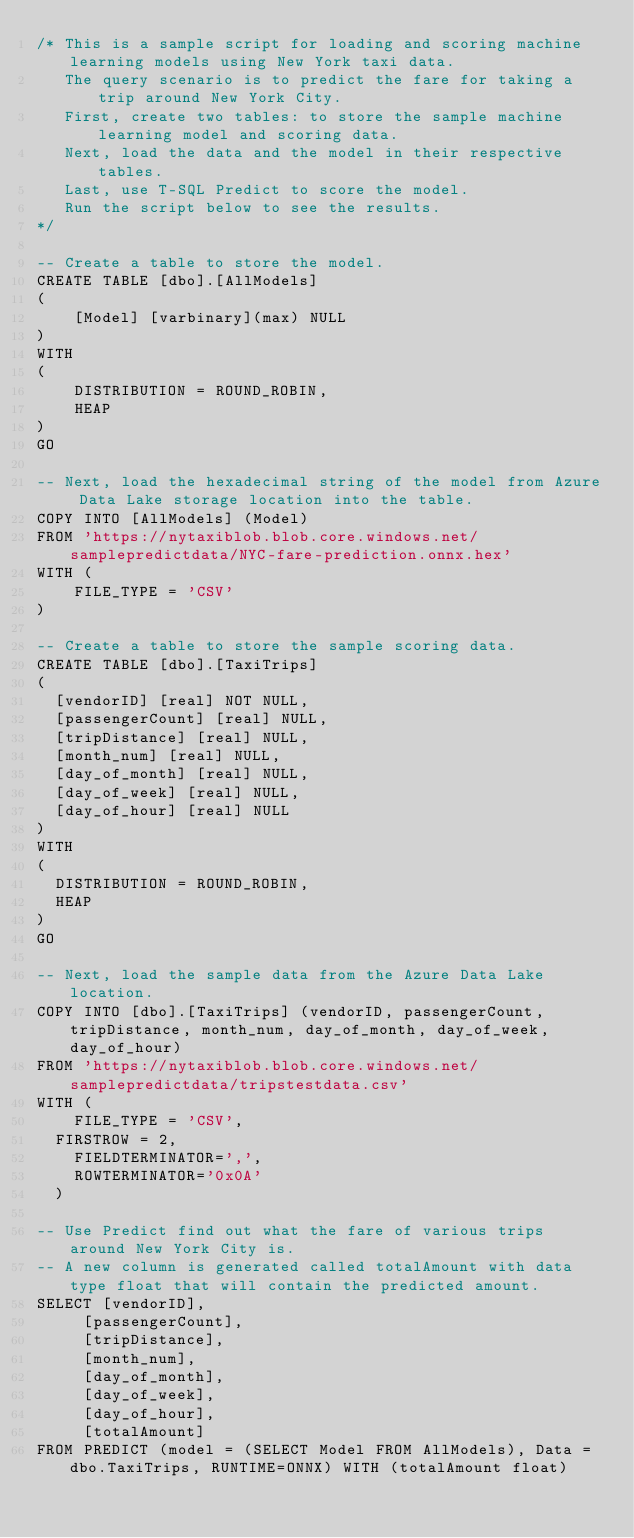<code> <loc_0><loc_0><loc_500><loc_500><_SQL_>/* This is a sample script for loading and scoring machine learning models using New York taxi data.
   The query scenario is to predict the fare for taking a trip around New York City.
   First, create two tables: to store the sample machine learning model and scoring data.
   Next, load the data and the model in their respective tables.
   Last, use T-SQL Predict to score the model.
   Run the script below to see the results.
*/

-- Create a table to store the model.
CREATE TABLE [dbo].[AllModels]
(
    [Model] [varbinary](max) NULL
)
WITH
(
    DISTRIBUTION = ROUND_ROBIN,
    HEAP
)
GO

-- Next, load the hexadecimal string of the model from Azure Data Lake storage location into the table.
COPY INTO [AllModels] (Model)
FROM 'https://nytaxiblob.blob.core.windows.net/samplepredictdata/NYC-fare-prediction.onnx.hex'
WITH (
    FILE_TYPE = 'CSV'
)

-- Create a table to store the sample scoring data.
CREATE TABLE [dbo].[TaxiTrips]
(
	[vendorID] [real] NOT NULL,
	[passengerCount] [real] NULL,
	[tripDistance] [real] NULL,
	[month_num] [real] NULL,
	[day_of_month] [real] NULL,
	[day_of_week] [real] NULL,
	[day_of_hour] [real] NULL
)
WITH
(
	DISTRIBUTION = ROUND_ROBIN,
	HEAP
)
GO

-- Next, load the sample data from the Azure Data Lake location.
COPY INTO [dbo].[TaxiTrips] (vendorID, passengerCount, tripDistance, month_num, day_of_month, day_of_week, day_of_hour)
FROM 'https://nytaxiblob.blob.core.windows.net/samplepredictdata/tripstestdata.csv'
WITH (
    FILE_TYPE = 'CSV',
	FIRSTROW = 2,
    FIELDTERMINATOR=',',
    ROWTERMINATOR='0x0A'
	)

-- Use Predict find out what the fare of various trips around New York City is.
-- A new column is generated called totalAmount with data type float that will contain the predicted amount.
SELECT [vendorID],
 	   [passengerCount],
	   [tripDistance],
	   [month_num],
	   [day_of_month],
	   [day_of_week],
	   [day_of_hour],
	   [totalAmount]
FROM PREDICT (model = (SELECT Model FROM AllModels), Data = dbo.TaxiTrips, RUNTIME=ONNX) WITH (totalAmount float)
</code> 